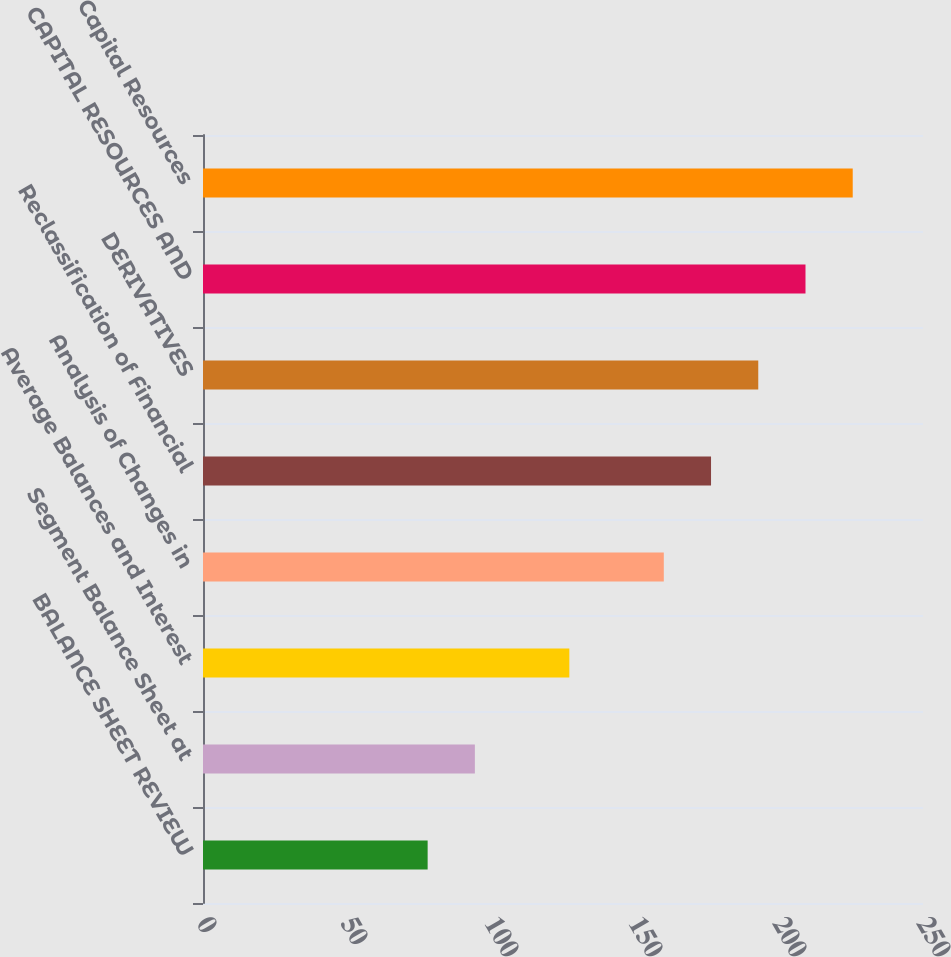Convert chart. <chart><loc_0><loc_0><loc_500><loc_500><bar_chart><fcel>BALANCE SHEET REVIEW<fcel>Segment Balance Sheet at<fcel>Average Balances and Interest<fcel>Analysis of Changes in<fcel>Reclassification of Financial<fcel>DERIVATIVES<fcel>CAPITAL RESOURCES AND<fcel>Capital Resources<nl><fcel>78<fcel>94.4<fcel>127.2<fcel>160<fcel>176.4<fcel>192.8<fcel>209.2<fcel>225.6<nl></chart> 